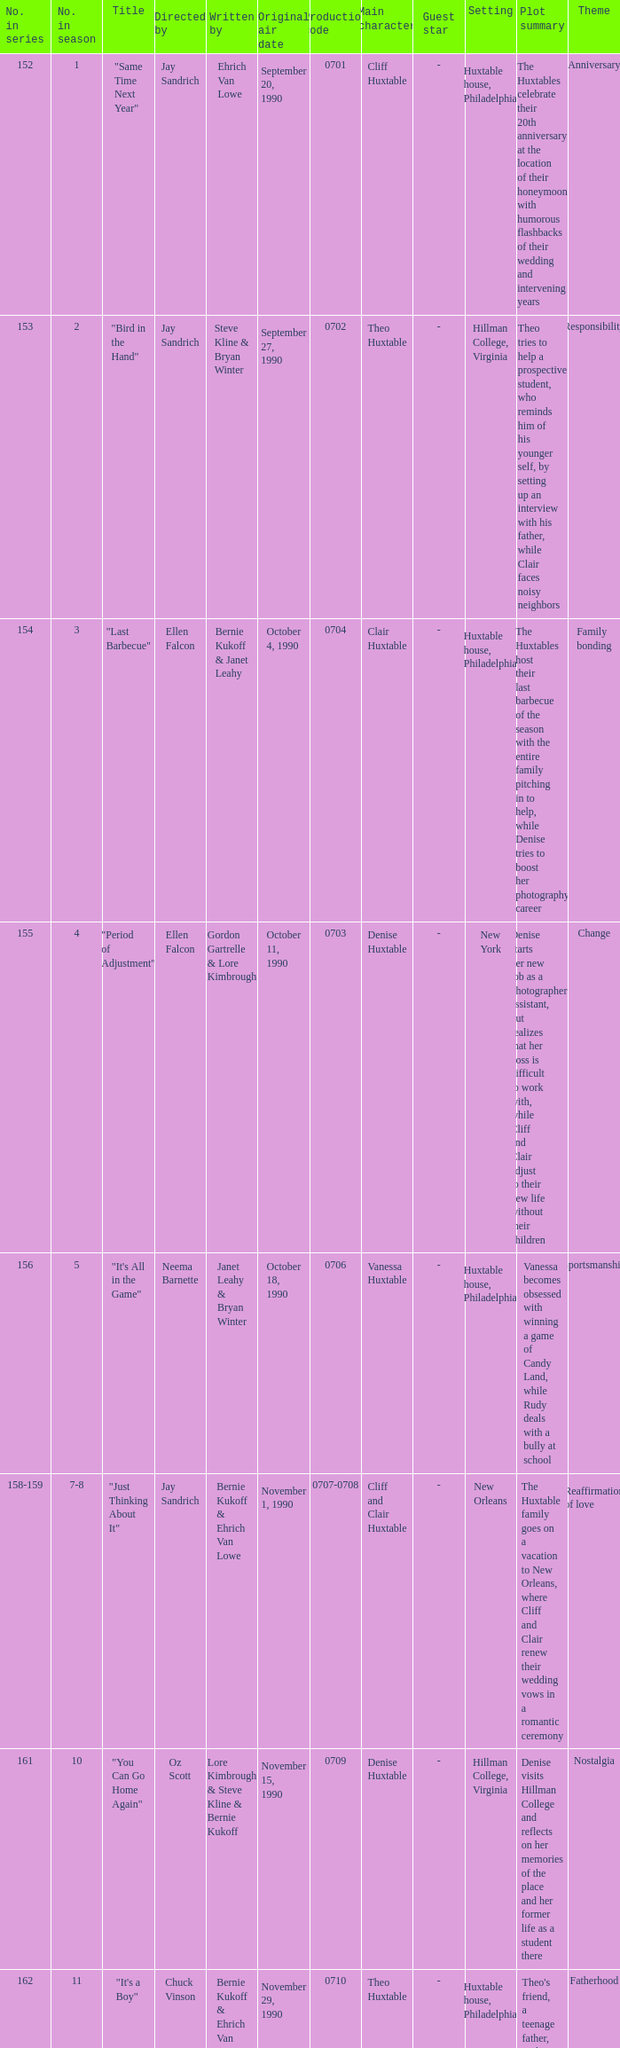The episode "adventures in babysitting" had what number in the season? 17.0. 